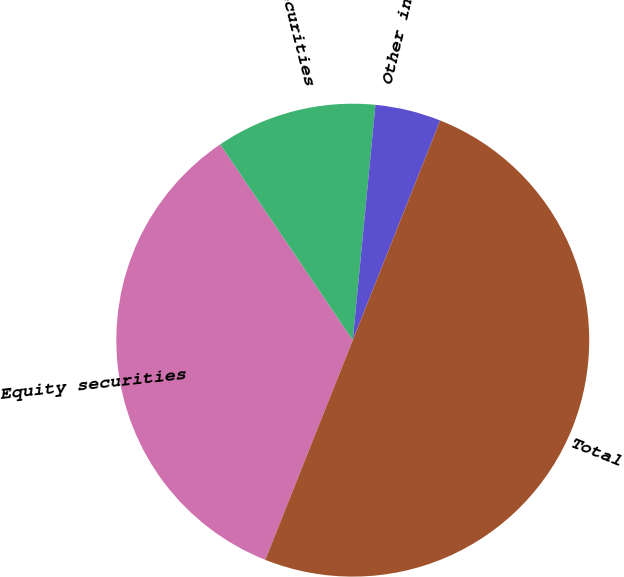Convert chart to OTSL. <chart><loc_0><loc_0><loc_500><loc_500><pie_chart><fcel>Equity securities<fcel>Debt securities<fcel>Other including cash<fcel>Total<nl><fcel>34.5%<fcel>11.0%<fcel>4.5%<fcel>50.0%<nl></chart> 